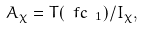<formula> <loc_0><loc_0><loc_500><loc_500>A _ { \chi } = T ( \ f c _ { \ 1 } ) / I _ { \chi } ,</formula> 